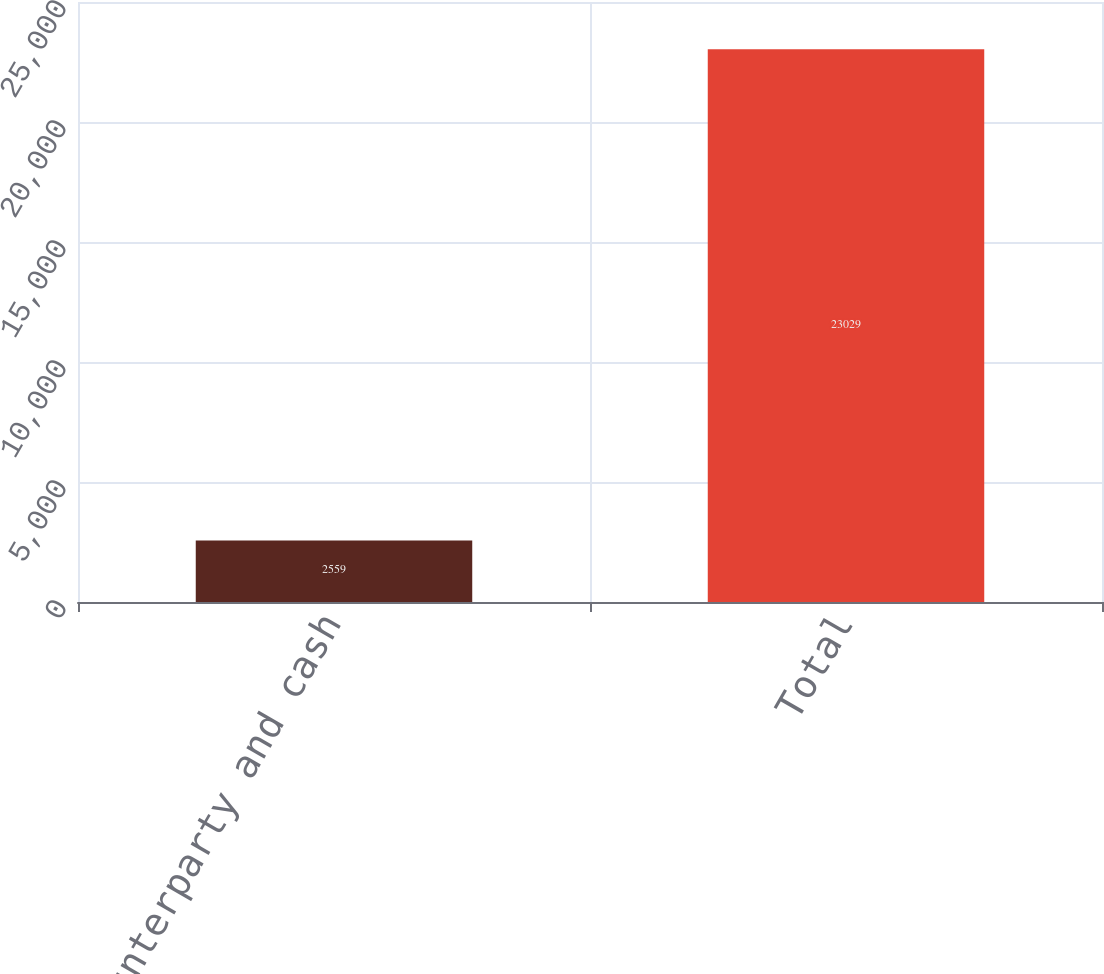Convert chart. <chart><loc_0><loc_0><loc_500><loc_500><bar_chart><fcel>Counterparty and cash<fcel>Total<nl><fcel>2559<fcel>23029<nl></chart> 